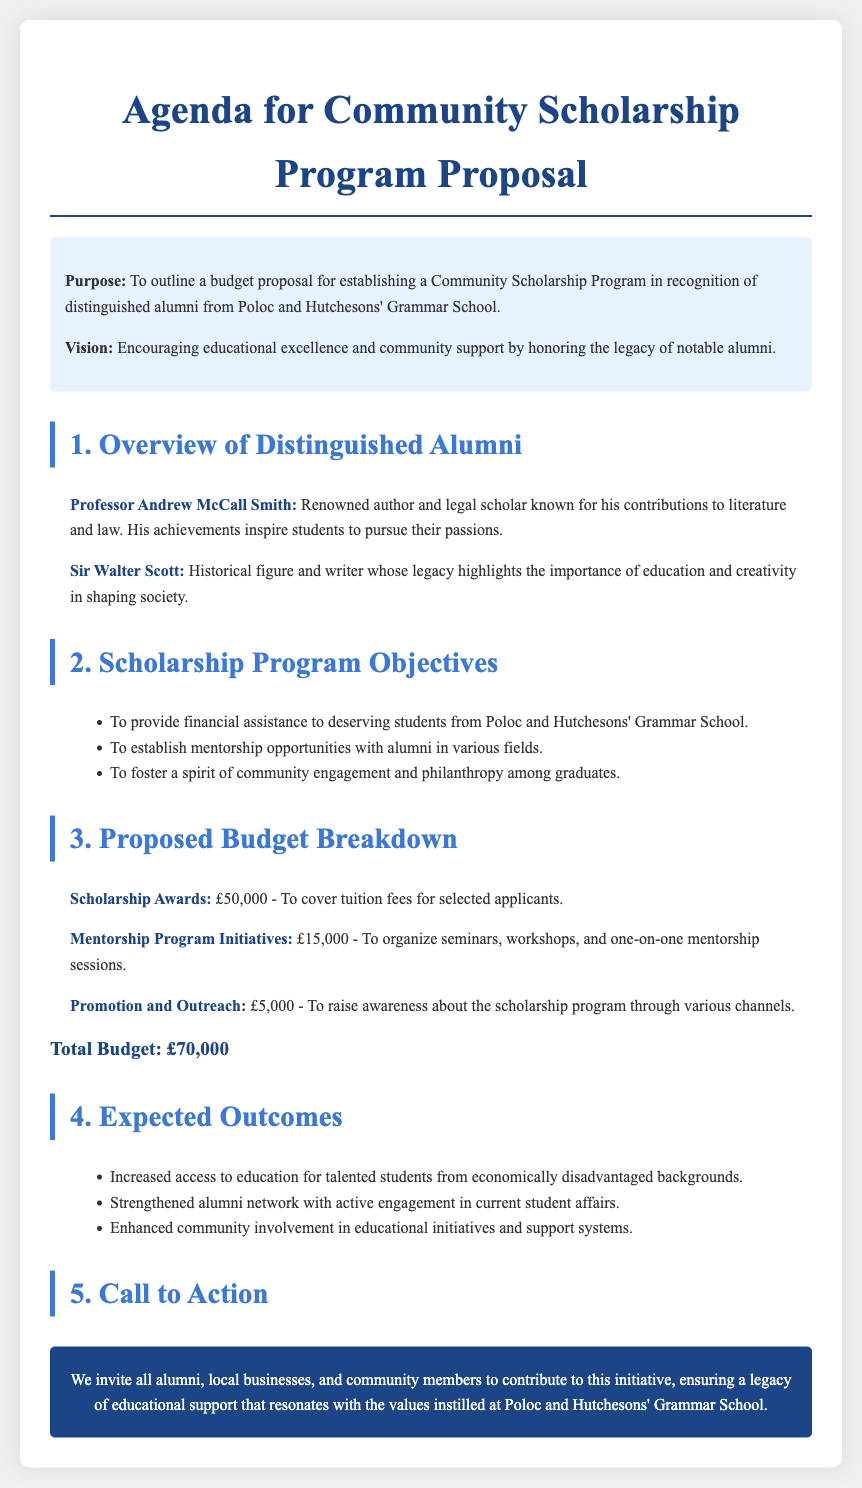What is the purpose of the proposal? The purpose outlines the goal of establishing a Community Scholarship Program.
Answer: To outline a budget proposal for establishing a Community Scholarship Program in recognition of distinguished alumni from Poloc and Hutchesons' Grammar School Who is a notable alumni mentioned in the agenda? This question requires identifying a distinguished individual highlighted in the document.
Answer: Professor Andrew McCall Smith What is the budget for scholarship awards? This focuses on the specific financial allocation for a key program component.
Answer: £50,000 How many objectives are outlined in the scholarship program? The question captures the total count of program objectives listed.
Answer: Three What is one expected outcome of the program? This asks for a specific result anticipated from implementing the scholarship program.
Answer: Increased access to education for talented students from economically disadvantaged backgrounds What is the total budget proposed? This question seeks the overall financial requirement for the scholarship program.
Answer: £70,000 What type of opportunities will be established with alumni? This encourages the reader to identify the type of engagement between students and alumni.
Answer: Mentorship opportunities What is the budget for mentorship program initiatives? The question focuses on the financial allocation for mentor-related activities.
Answer: £15,000 